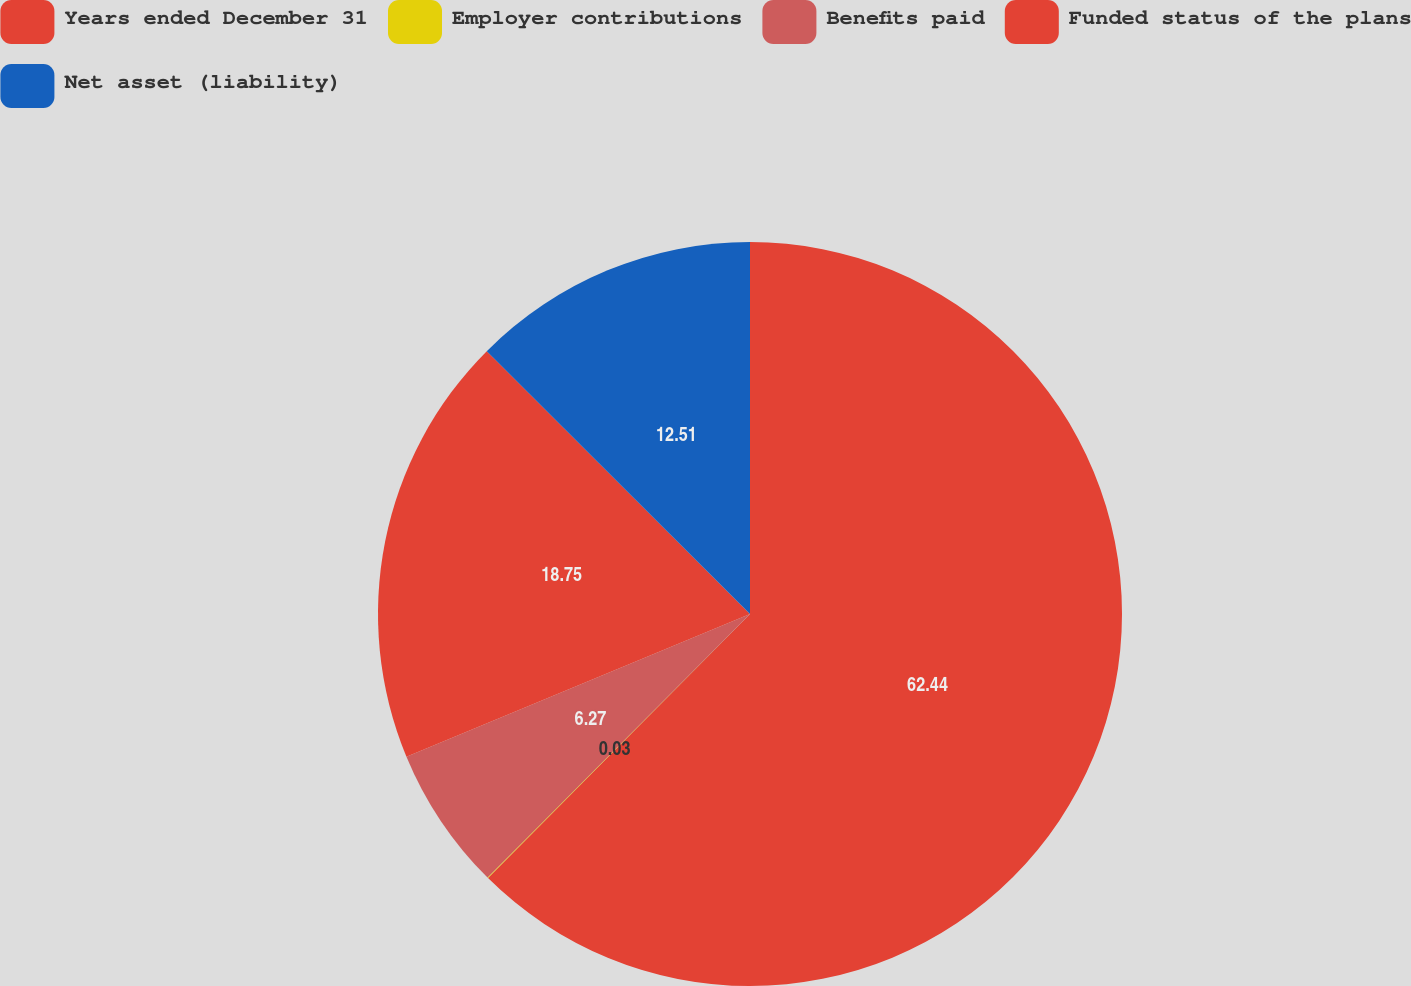Convert chart. <chart><loc_0><loc_0><loc_500><loc_500><pie_chart><fcel>Years ended December 31<fcel>Employer contributions<fcel>Benefits paid<fcel>Funded status of the plans<fcel>Net asset (liability)<nl><fcel>62.43%<fcel>0.03%<fcel>6.27%<fcel>18.75%<fcel>12.51%<nl></chart> 